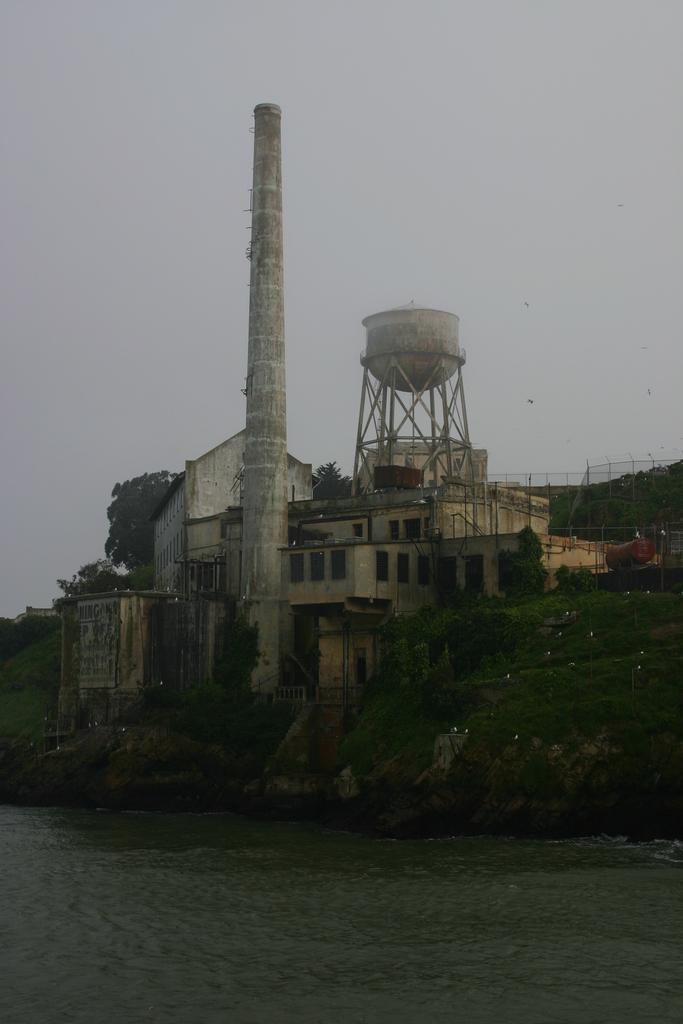Describe this image in one or two sentences. At the bottom of the picture, we see water. There are trees and a building in white color. This might be a factory. Behind the factory, we see a fence and trees. At the top of the picture, we see the sky. 